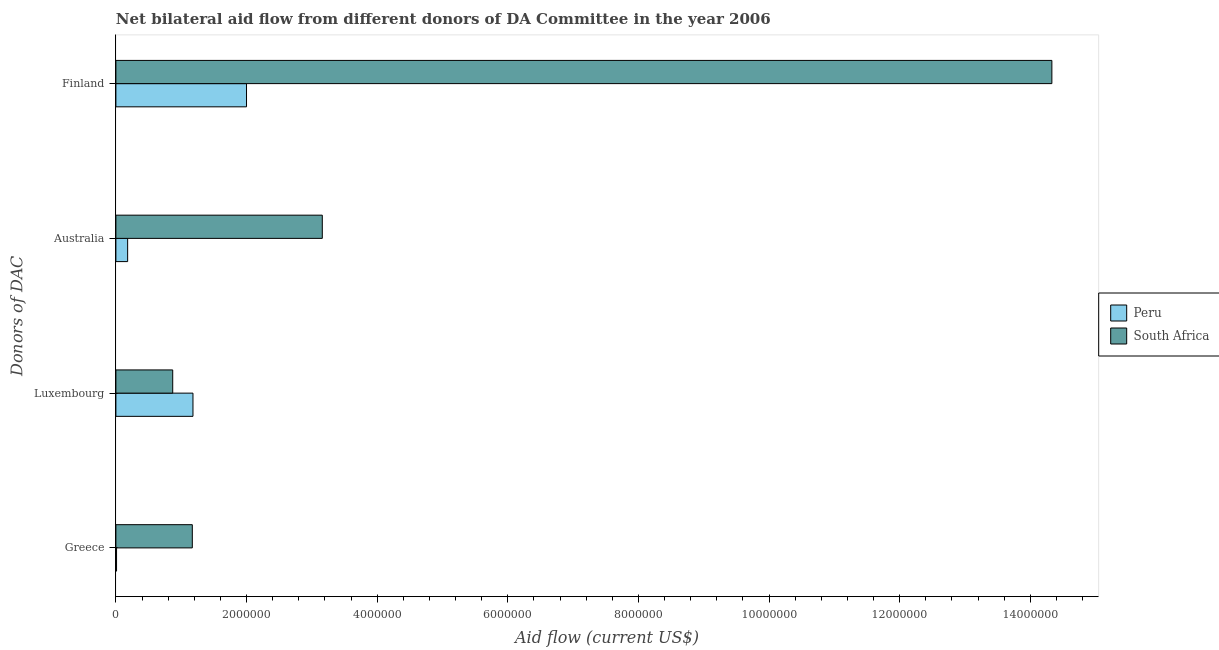Are the number of bars per tick equal to the number of legend labels?
Keep it short and to the point. Yes. Are the number of bars on each tick of the Y-axis equal?
Give a very brief answer. Yes. How many bars are there on the 2nd tick from the top?
Provide a short and direct response. 2. What is the label of the 2nd group of bars from the top?
Give a very brief answer. Australia. What is the amount of aid given by greece in South Africa?
Your answer should be very brief. 1.17e+06. Across all countries, what is the maximum amount of aid given by luxembourg?
Your response must be concise. 1.18e+06. Across all countries, what is the minimum amount of aid given by finland?
Your response must be concise. 2.00e+06. In which country was the amount of aid given by greece maximum?
Ensure brevity in your answer.  South Africa. In which country was the amount of aid given by finland minimum?
Provide a succinct answer. Peru. What is the total amount of aid given by luxembourg in the graph?
Give a very brief answer. 2.05e+06. What is the difference between the amount of aid given by greece in South Africa and that in Peru?
Your answer should be very brief. 1.16e+06. What is the difference between the amount of aid given by luxembourg in Peru and the amount of aid given by australia in South Africa?
Your answer should be compact. -1.98e+06. What is the average amount of aid given by finland per country?
Your answer should be very brief. 8.16e+06. What is the difference between the amount of aid given by luxembourg and amount of aid given by greece in South Africa?
Provide a succinct answer. -3.00e+05. In how many countries, is the amount of aid given by greece greater than 5600000 US$?
Make the answer very short. 0. What is the ratio of the amount of aid given by finland in South Africa to that in Peru?
Keep it short and to the point. 7.17. Is the amount of aid given by greece in South Africa less than that in Peru?
Provide a short and direct response. No. What is the difference between the highest and the second highest amount of aid given by luxembourg?
Make the answer very short. 3.10e+05. What is the difference between the highest and the lowest amount of aid given by luxembourg?
Your answer should be very brief. 3.10e+05. Is the sum of the amount of aid given by australia in Peru and South Africa greater than the maximum amount of aid given by finland across all countries?
Your answer should be very brief. No. What does the 1st bar from the top in Greece represents?
Give a very brief answer. South Africa. What does the 1st bar from the bottom in Greece represents?
Give a very brief answer. Peru. Are all the bars in the graph horizontal?
Offer a terse response. Yes. How many countries are there in the graph?
Keep it short and to the point. 2. What is the difference between two consecutive major ticks on the X-axis?
Your answer should be compact. 2.00e+06. Are the values on the major ticks of X-axis written in scientific E-notation?
Offer a terse response. No. Does the graph contain grids?
Provide a succinct answer. No. Where does the legend appear in the graph?
Your response must be concise. Center right. How many legend labels are there?
Provide a short and direct response. 2. What is the title of the graph?
Offer a terse response. Net bilateral aid flow from different donors of DA Committee in the year 2006. What is the label or title of the Y-axis?
Give a very brief answer. Donors of DAC. What is the Aid flow (current US$) in Peru in Greece?
Give a very brief answer. 10000. What is the Aid flow (current US$) of South Africa in Greece?
Your answer should be very brief. 1.17e+06. What is the Aid flow (current US$) of Peru in Luxembourg?
Provide a short and direct response. 1.18e+06. What is the Aid flow (current US$) in South Africa in Luxembourg?
Provide a succinct answer. 8.70e+05. What is the Aid flow (current US$) of South Africa in Australia?
Provide a succinct answer. 3.16e+06. What is the Aid flow (current US$) in South Africa in Finland?
Make the answer very short. 1.43e+07. Across all Donors of DAC, what is the maximum Aid flow (current US$) in South Africa?
Your answer should be very brief. 1.43e+07. Across all Donors of DAC, what is the minimum Aid flow (current US$) of Peru?
Provide a succinct answer. 10000. Across all Donors of DAC, what is the minimum Aid flow (current US$) of South Africa?
Keep it short and to the point. 8.70e+05. What is the total Aid flow (current US$) in Peru in the graph?
Offer a terse response. 3.37e+06. What is the total Aid flow (current US$) of South Africa in the graph?
Your answer should be very brief. 1.95e+07. What is the difference between the Aid flow (current US$) of Peru in Greece and that in Luxembourg?
Your response must be concise. -1.17e+06. What is the difference between the Aid flow (current US$) of Peru in Greece and that in Australia?
Provide a short and direct response. -1.70e+05. What is the difference between the Aid flow (current US$) in South Africa in Greece and that in Australia?
Offer a very short reply. -1.99e+06. What is the difference between the Aid flow (current US$) of Peru in Greece and that in Finland?
Your answer should be compact. -1.99e+06. What is the difference between the Aid flow (current US$) in South Africa in Greece and that in Finland?
Your answer should be very brief. -1.32e+07. What is the difference between the Aid flow (current US$) of Peru in Luxembourg and that in Australia?
Your response must be concise. 1.00e+06. What is the difference between the Aid flow (current US$) of South Africa in Luxembourg and that in Australia?
Provide a succinct answer. -2.29e+06. What is the difference between the Aid flow (current US$) in Peru in Luxembourg and that in Finland?
Provide a short and direct response. -8.20e+05. What is the difference between the Aid flow (current US$) in South Africa in Luxembourg and that in Finland?
Provide a short and direct response. -1.35e+07. What is the difference between the Aid flow (current US$) in Peru in Australia and that in Finland?
Make the answer very short. -1.82e+06. What is the difference between the Aid flow (current US$) of South Africa in Australia and that in Finland?
Give a very brief answer. -1.12e+07. What is the difference between the Aid flow (current US$) in Peru in Greece and the Aid flow (current US$) in South Africa in Luxembourg?
Your answer should be very brief. -8.60e+05. What is the difference between the Aid flow (current US$) in Peru in Greece and the Aid flow (current US$) in South Africa in Australia?
Offer a very short reply. -3.15e+06. What is the difference between the Aid flow (current US$) in Peru in Greece and the Aid flow (current US$) in South Africa in Finland?
Make the answer very short. -1.43e+07. What is the difference between the Aid flow (current US$) in Peru in Luxembourg and the Aid flow (current US$) in South Africa in Australia?
Ensure brevity in your answer.  -1.98e+06. What is the difference between the Aid flow (current US$) in Peru in Luxembourg and the Aid flow (current US$) in South Africa in Finland?
Make the answer very short. -1.32e+07. What is the difference between the Aid flow (current US$) of Peru in Australia and the Aid flow (current US$) of South Africa in Finland?
Your answer should be very brief. -1.42e+07. What is the average Aid flow (current US$) of Peru per Donors of DAC?
Give a very brief answer. 8.42e+05. What is the average Aid flow (current US$) in South Africa per Donors of DAC?
Make the answer very short. 4.88e+06. What is the difference between the Aid flow (current US$) of Peru and Aid flow (current US$) of South Africa in Greece?
Your response must be concise. -1.16e+06. What is the difference between the Aid flow (current US$) in Peru and Aid flow (current US$) in South Africa in Luxembourg?
Make the answer very short. 3.10e+05. What is the difference between the Aid flow (current US$) in Peru and Aid flow (current US$) in South Africa in Australia?
Offer a very short reply. -2.98e+06. What is the difference between the Aid flow (current US$) in Peru and Aid flow (current US$) in South Africa in Finland?
Make the answer very short. -1.23e+07. What is the ratio of the Aid flow (current US$) in Peru in Greece to that in Luxembourg?
Offer a very short reply. 0.01. What is the ratio of the Aid flow (current US$) in South Africa in Greece to that in Luxembourg?
Make the answer very short. 1.34. What is the ratio of the Aid flow (current US$) in Peru in Greece to that in Australia?
Give a very brief answer. 0.06. What is the ratio of the Aid flow (current US$) in South Africa in Greece to that in Australia?
Give a very brief answer. 0.37. What is the ratio of the Aid flow (current US$) of Peru in Greece to that in Finland?
Offer a very short reply. 0.01. What is the ratio of the Aid flow (current US$) of South Africa in Greece to that in Finland?
Your answer should be very brief. 0.08. What is the ratio of the Aid flow (current US$) in Peru in Luxembourg to that in Australia?
Provide a short and direct response. 6.56. What is the ratio of the Aid flow (current US$) in South Africa in Luxembourg to that in Australia?
Your response must be concise. 0.28. What is the ratio of the Aid flow (current US$) of Peru in Luxembourg to that in Finland?
Provide a short and direct response. 0.59. What is the ratio of the Aid flow (current US$) of South Africa in Luxembourg to that in Finland?
Your response must be concise. 0.06. What is the ratio of the Aid flow (current US$) of Peru in Australia to that in Finland?
Keep it short and to the point. 0.09. What is the ratio of the Aid flow (current US$) of South Africa in Australia to that in Finland?
Provide a short and direct response. 0.22. What is the difference between the highest and the second highest Aid flow (current US$) in Peru?
Provide a succinct answer. 8.20e+05. What is the difference between the highest and the second highest Aid flow (current US$) in South Africa?
Make the answer very short. 1.12e+07. What is the difference between the highest and the lowest Aid flow (current US$) of Peru?
Offer a very short reply. 1.99e+06. What is the difference between the highest and the lowest Aid flow (current US$) in South Africa?
Your answer should be very brief. 1.35e+07. 